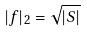<formula> <loc_0><loc_0><loc_500><loc_500>| f | _ { 2 } = \sqrt { | S | }</formula> 